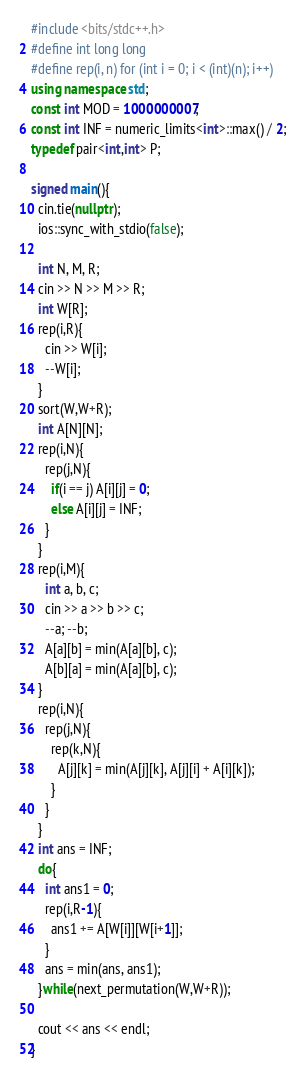Convert code to text. <code><loc_0><loc_0><loc_500><loc_500><_C++_>#include <bits/stdc++.h>
#define int long long
#define rep(i, n) for (int i = 0; i < (int)(n); i++)
using namespace std;
const int MOD = 1000000007;
const int INF = numeric_limits<int>::max() / 2;
typedef pair<int,int> P;

signed main(){
  cin.tie(nullptr);
  ios::sync_with_stdio(false);

  int N, M, R;
  cin >> N >> M >> R;
  int W[R];
  rep(i,R){
    cin >> W[i];
    --W[i];
  }
  sort(W,W+R);
  int A[N][N];
  rep(i,N){
    rep(j,N){
      if(i == j) A[i][j] = 0;
      else A[i][j] = INF;
    }
  }
  rep(i,M){
    int a, b, c;
    cin >> a >> b >> c;
    --a; --b;
    A[a][b] = min(A[a][b], c);
    A[b][a] = min(A[a][b], c);
  }
  rep(i,N){
    rep(j,N){
      rep(k,N){
        A[j][k] = min(A[j][k], A[j][i] + A[i][k]);
      }
    }
  }
  int ans = INF;
  do{
    int ans1 = 0;
    rep(i,R-1){
      ans1 += A[W[i]][W[i+1]];
    }
    ans = min(ans, ans1);
  }while(next_permutation(W,W+R));

  cout << ans << endl;
}</code> 